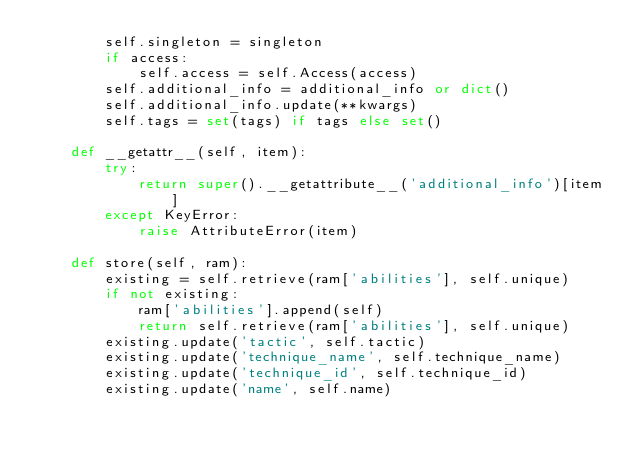Convert code to text. <code><loc_0><loc_0><loc_500><loc_500><_Python_>        self.singleton = singleton
        if access:
            self.access = self.Access(access)
        self.additional_info = additional_info or dict()
        self.additional_info.update(**kwargs)
        self.tags = set(tags) if tags else set()

    def __getattr__(self, item):
        try:
            return super().__getattribute__('additional_info')[item]
        except KeyError:
            raise AttributeError(item)

    def store(self, ram):
        existing = self.retrieve(ram['abilities'], self.unique)
        if not existing:
            ram['abilities'].append(self)
            return self.retrieve(ram['abilities'], self.unique)
        existing.update('tactic', self.tactic)
        existing.update('technique_name', self.technique_name)
        existing.update('technique_id', self.technique_id)
        existing.update('name', self.name)</code> 